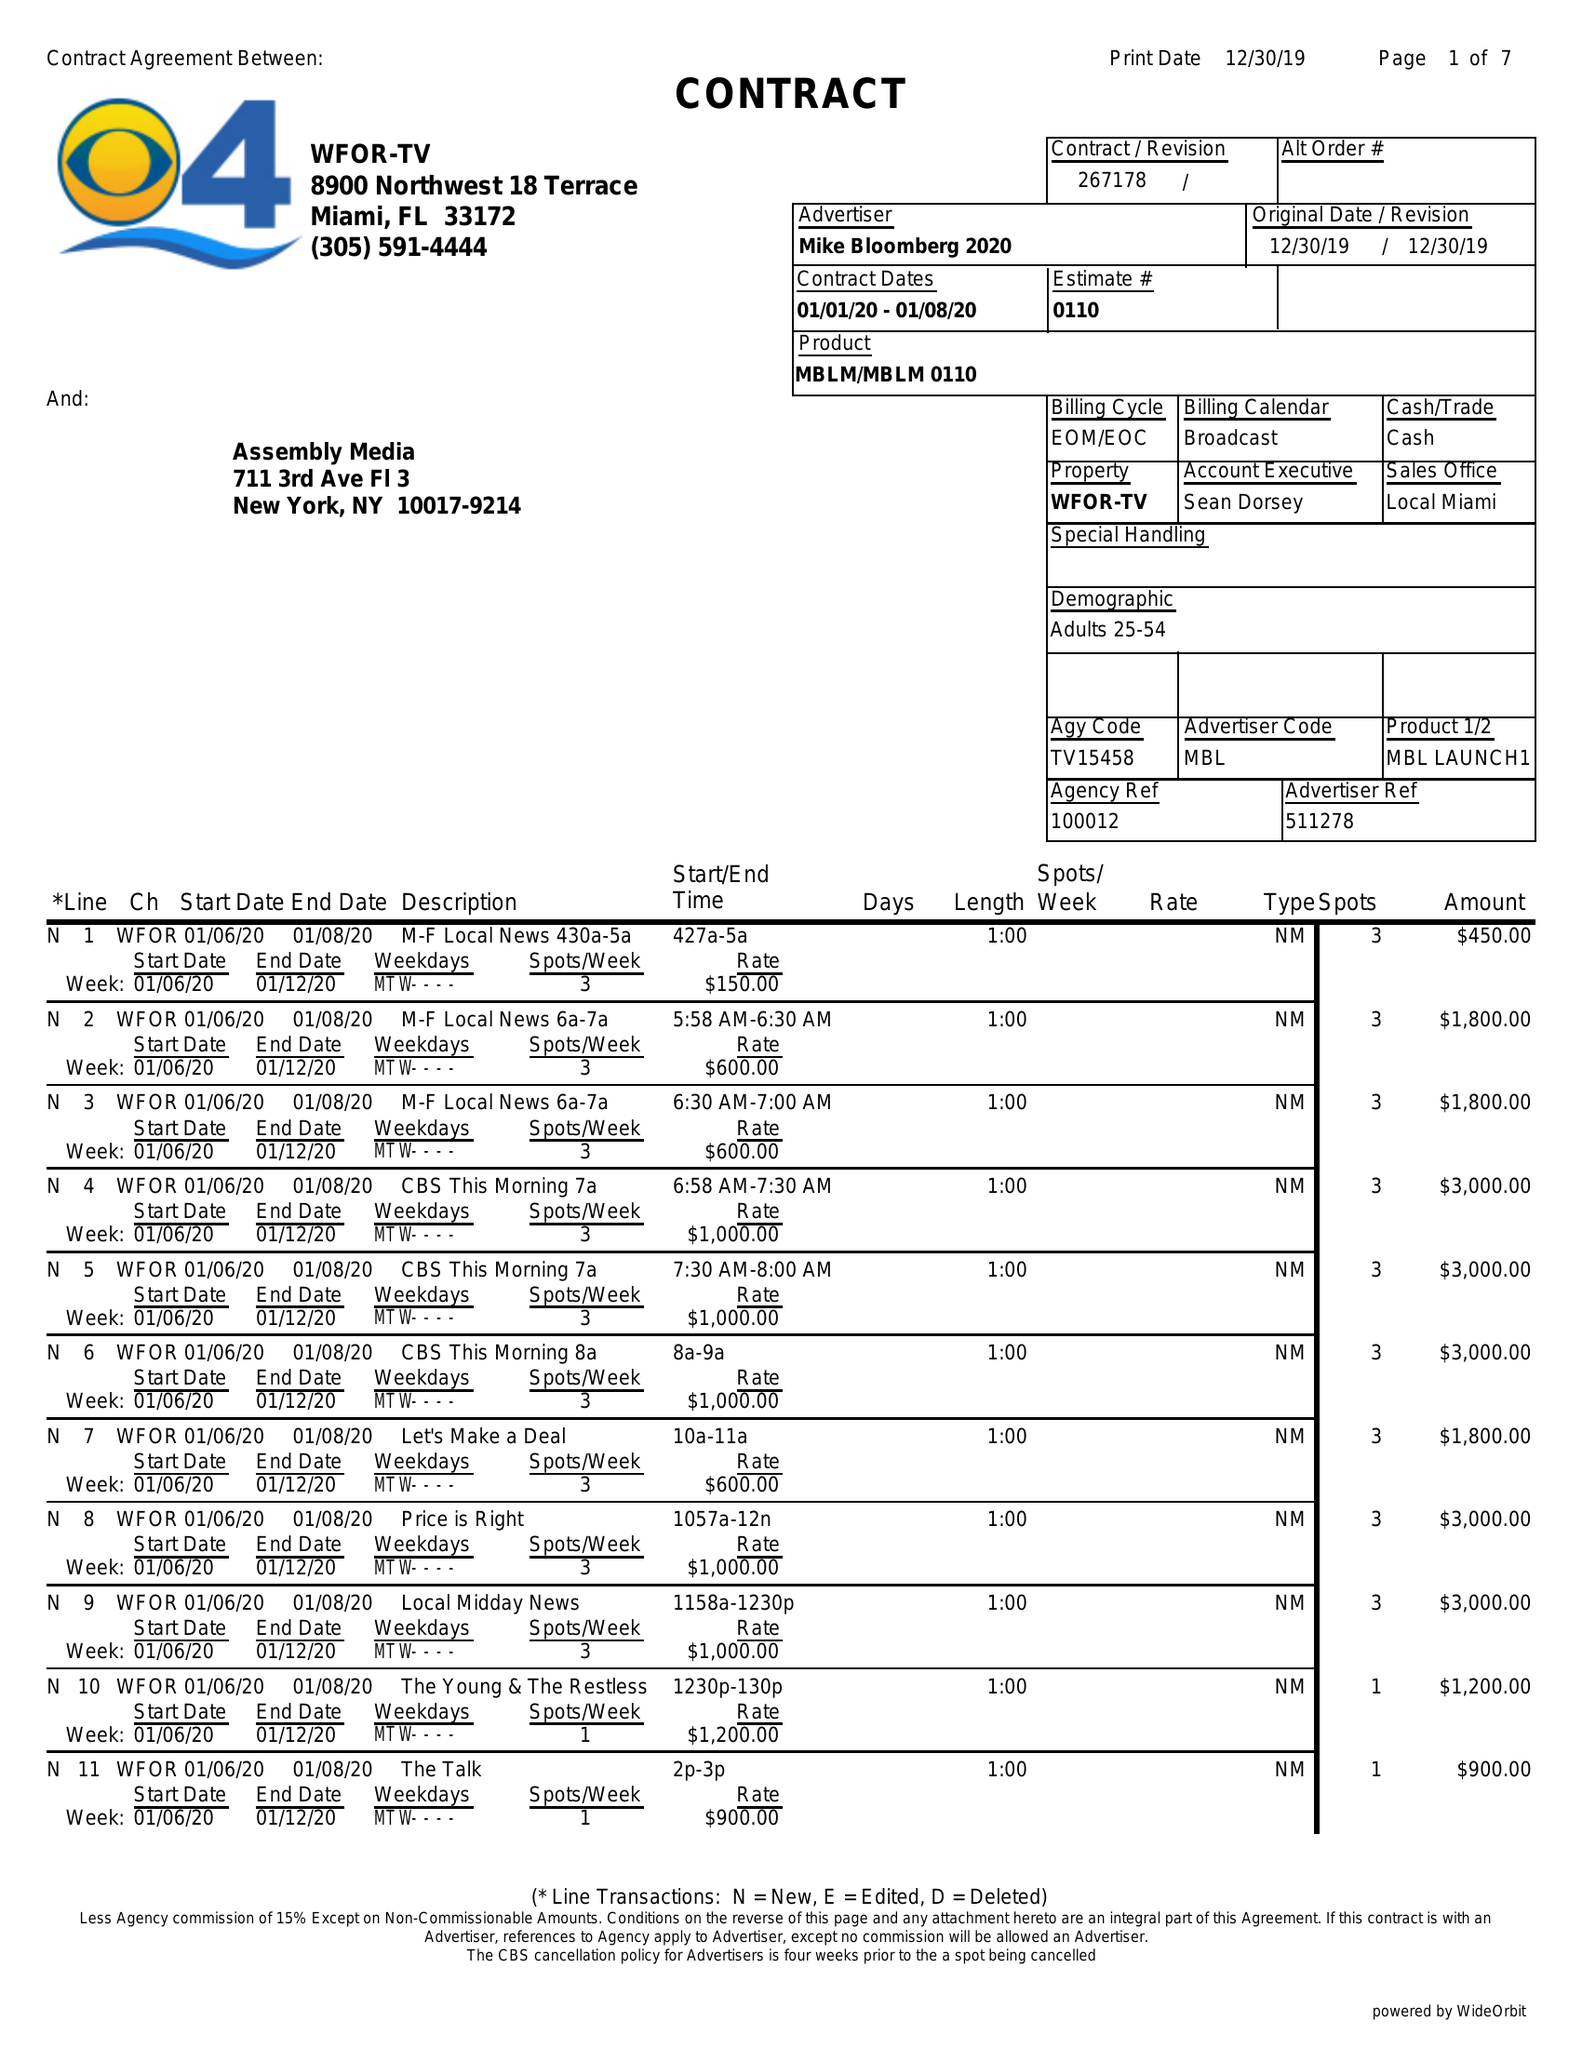What is the value for the contract_num?
Answer the question using a single word or phrase. 267178 